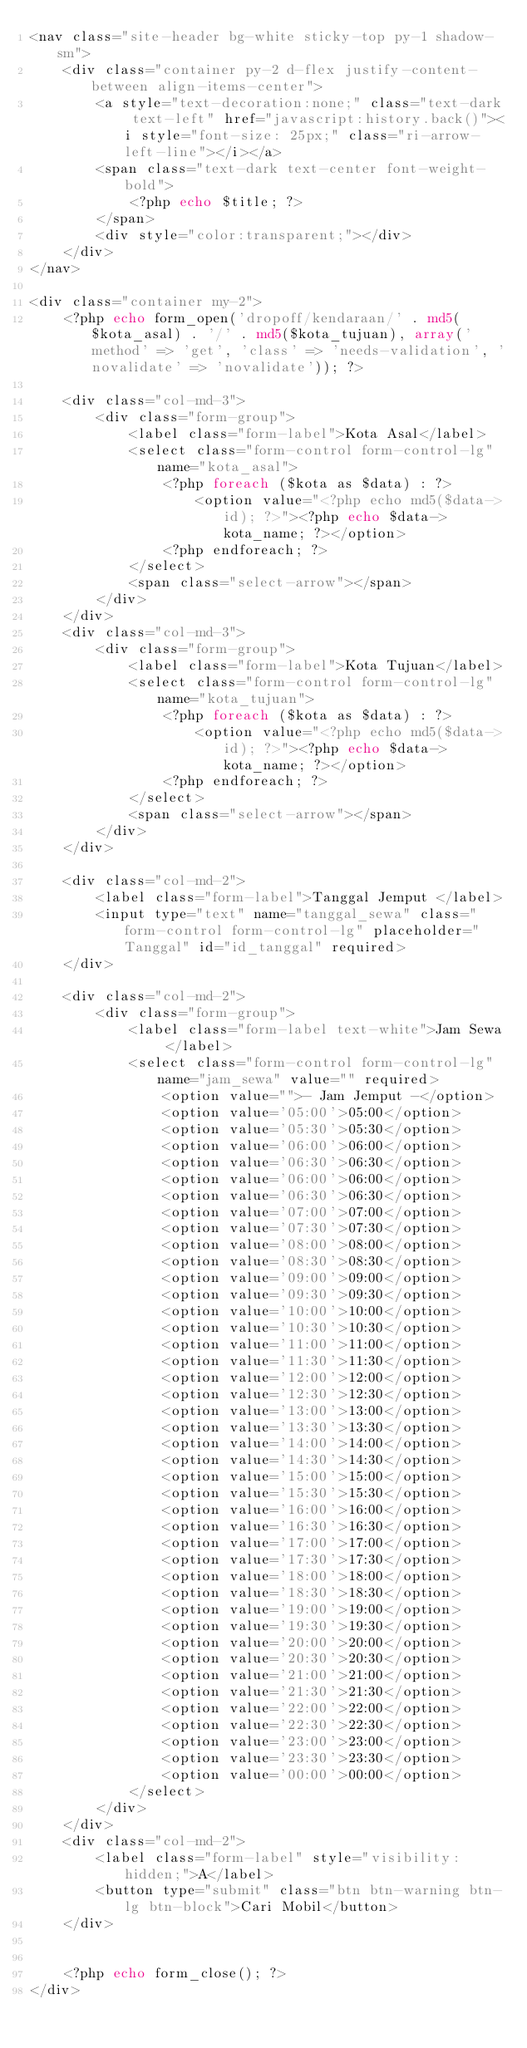<code> <loc_0><loc_0><loc_500><loc_500><_PHP_><nav class="site-header bg-white sticky-top py-1 shadow-sm">
    <div class="container py-2 d-flex justify-content-between align-items-center">
        <a style="text-decoration:none;" class="text-dark text-left" href="javascript:history.back()"><i style="font-size: 25px;" class="ri-arrow-left-line"></i></a>
        <span class="text-dark text-center font-weight-bold">
            <?php echo $title; ?>
        </span>
        <div style="color:transparent;"></div>
    </div>
</nav>

<div class="container my-2">
    <?php echo form_open('dropoff/kendaraan/' . md5($kota_asal) . '/' . md5($kota_tujuan), array('method' => 'get', 'class' => 'needs-validation', 'novalidate' => 'novalidate')); ?>

    <div class="col-md-3">
        <div class="form-group">
            <label class="form-label">Kota Asal</label>
            <select class="form-control form-control-lg" name="kota_asal">
                <?php foreach ($kota as $data) : ?>
                    <option value="<?php echo md5($data->id); ?>"><?php echo $data->kota_name; ?></option>
                <?php endforeach; ?>
            </select>
            <span class="select-arrow"></span>
        </div>
    </div>
    <div class="col-md-3">
        <div class="form-group">
            <label class="form-label">Kota Tujuan</label>
            <select class="form-control form-control-lg" name="kota_tujuan">
                <?php foreach ($kota as $data) : ?>
                    <option value="<?php echo md5($data->id); ?>"><?php echo $data->kota_name; ?></option>
                <?php endforeach; ?>
            </select>
            <span class="select-arrow"></span>
        </div>
    </div>

    <div class="col-md-2">
        <label class="form-label">Tanggal Jemput </label>
        <input type="text" name="tanggal_sewa" class="form-control form-control-lg" placeholder="Tanggal" id="id_tanggal" required>
    </div>

    <div class="col-md-2">
        <div class="form-group">
            <label class="form-label text-white">Jam Sewa </label>
            <select class="form-control form-control-lg" name="jam_sewa" value="" required>
                <option value="">- Jam Jemput -</option>
                <option value='05:00'>05:00</option>
                <option value='05:30'>05:30</option>
                <option value='06:00'>06:00</option>
                <option value='06:30'>06:30</option>
                <option value='06:00'>06:00</option>
                <option value='06:30'>06:30</option>
                <option value='07:00'>07:00</option>
                <option value='07:30'>07:30</option>
                <option value='08:00'>08:00</option>
                <option value='08:30'>08:30</option>
                <option value='09:00'>09:00</option>
                <option value='09:30'>09:30</option>
                <option value='10:00'>10:00</option>
                <option value='10:30'>10:30</option>
                <option value='11:00'>11:00</option>
                <option value='11:30'>11:30</option>
                <option value='12:00'>12:00</option>
                <option value='12:30'>12:30</option>
                <option value='13:00'>13:00</option>
                <option value='13:30'>13:30</option>
                <option value='14:00'>14:00</option>
                <option value='14:30'>14:30</option>
                <option value='15:00'>15:00</option>
                <option value='15:30'>15:30</option>
                <option value='16:00'>16:00</option>
                <option value='16:30'>16:30</option>
                <option value='17:00'>17:00</option>
                <option value='17:30'>17:30</option>
                <option value='18:00'>18:00</option>
                <option value='18:30'>18:30</option>
                <option value='19:00'>19:00</option>
                <option value='19:30'>19:30</option>
                <option value='20:00'>20:00</option>
                <option value='20:30'>20:30</option>
                <option value='21:00'>21:00</option>
                <option value='21:30'>21:30</option>
                <option value='22:00'>22:00</option>
                <option value='22:30'>22:30</option>
                <option value='23:00'>23:00</option>
                <option value='23:30'>23:30</option>
                <option value='00:00'>00:00</option>
            </select>
        </div>
    </div>
    <div class="col-md-2">
        <label class="form-label" style="visibility: hidden;">A</label>
        <button type="submit" class="btn btn-warning btn-lg btn-block">Cari Mobil</button>
    </div>


    <?php echo form_close(); ?>
</div></code> 